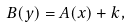<formula> <loc_0><loc_0><loc_500><loc_500>B ( y ) = A ( x ) + k ,</formula> 